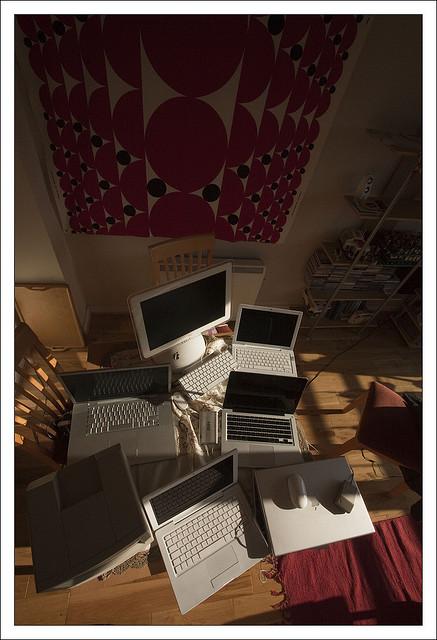How many laptops are present?
Keep it brief. 6. Are any of them in use in the photo?
Answer briefly. No. What are the electronics in this image?
Be succinct. Computers. 